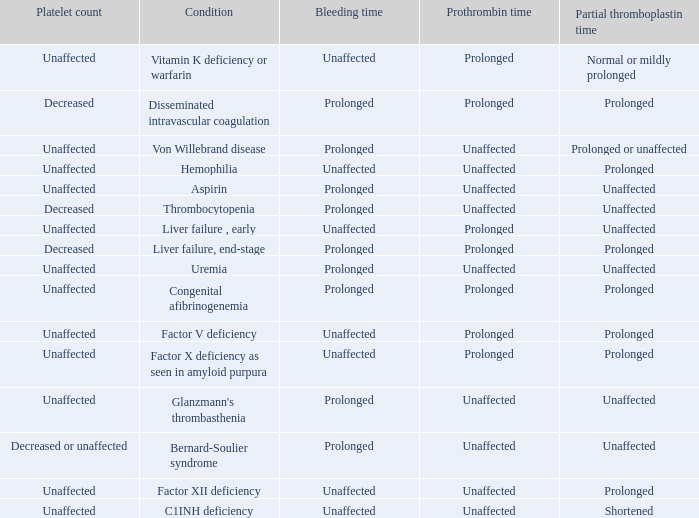Which partial thromboplastin time has a condition of liver failure , early? Unaffected. 